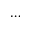<formula> <loc_0><loc_0><loc_500><loc_500>\dots</formula> 